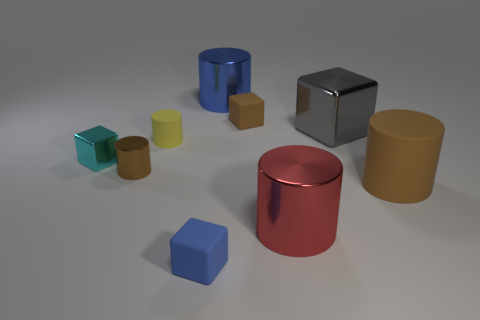Subtract all large metallic cylinders. How many cylinders are left? 3 Subtract all cyan blocks. How many blocks are left? 3 Add 1 small brown metal spheres. How many objects exist? 10 Subtract all matte cubes. Subtract all brown metal cylinders. How many objects are left? 6 Add 8 red cylinders. How many red cylinders are left? 9 Add 8 large purple metallic cubes. How many large purple metallic cubes exist? 8 Subtract 0 purple cubes. How many objects are left? 9 Subtract all cubes. How many objects are left? 5 Subtract 5 cylinders. How many cylinders are left? 0 Subtract all yellow blocks. Subtract all blue spheres. How many blocks are left? 4 